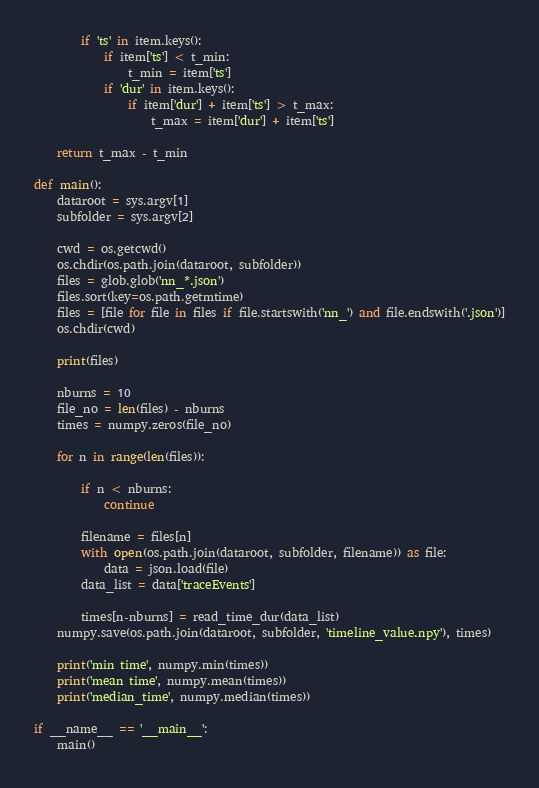<code> <loc_0><loc_0><loc_500><loc_500><_Python_>        if 'ts' in item.keys():
            if item['ts'] < t_min:
                t_min = item['ts']
            if 'dur' in item.keys():
                if item['dur'] + item['ts'] > t_max:
                    t_max = item['dur'] + item['ts']

    return t_max - t_min

def main():
    dataroot = sys.argv[1]
    subfolder = sys.argv[2]

    cwd = os.getcwd()
    os.chdir(os.path.join(dataroot, subfolder))
    files = glob.glob('nn_*.json')
    files.sort(key=os.path.getmtime)
    files = [file for file in files if file.startswith('nn_') and file.endswith('.json')]
    os.chdir(cwd)

    print(files)

    nburns = 10
    file_no = len(files) - nburns
    times = numpy.zeros(file_no)

    for n in range(len(files)):

        if n < nburns:
            continue

        filename = files[n]
        with open(os.path.join(dataroot, subfolder, filename)) as file:
            data = json.load(file)
        data_list = data['traceEvents']
        
        times[n-nburns] = read_time_dur(data_list)
    numpy.save(os.path.join(dataroot, subfolder, 'timeline_value.npy'), times)

    print('min time', numpy.min(times))
    print('mean time', numpy.mean(times))
    print('median_time', numpy.median(times))

if __name__ == '__main__':
    main()
</code> 